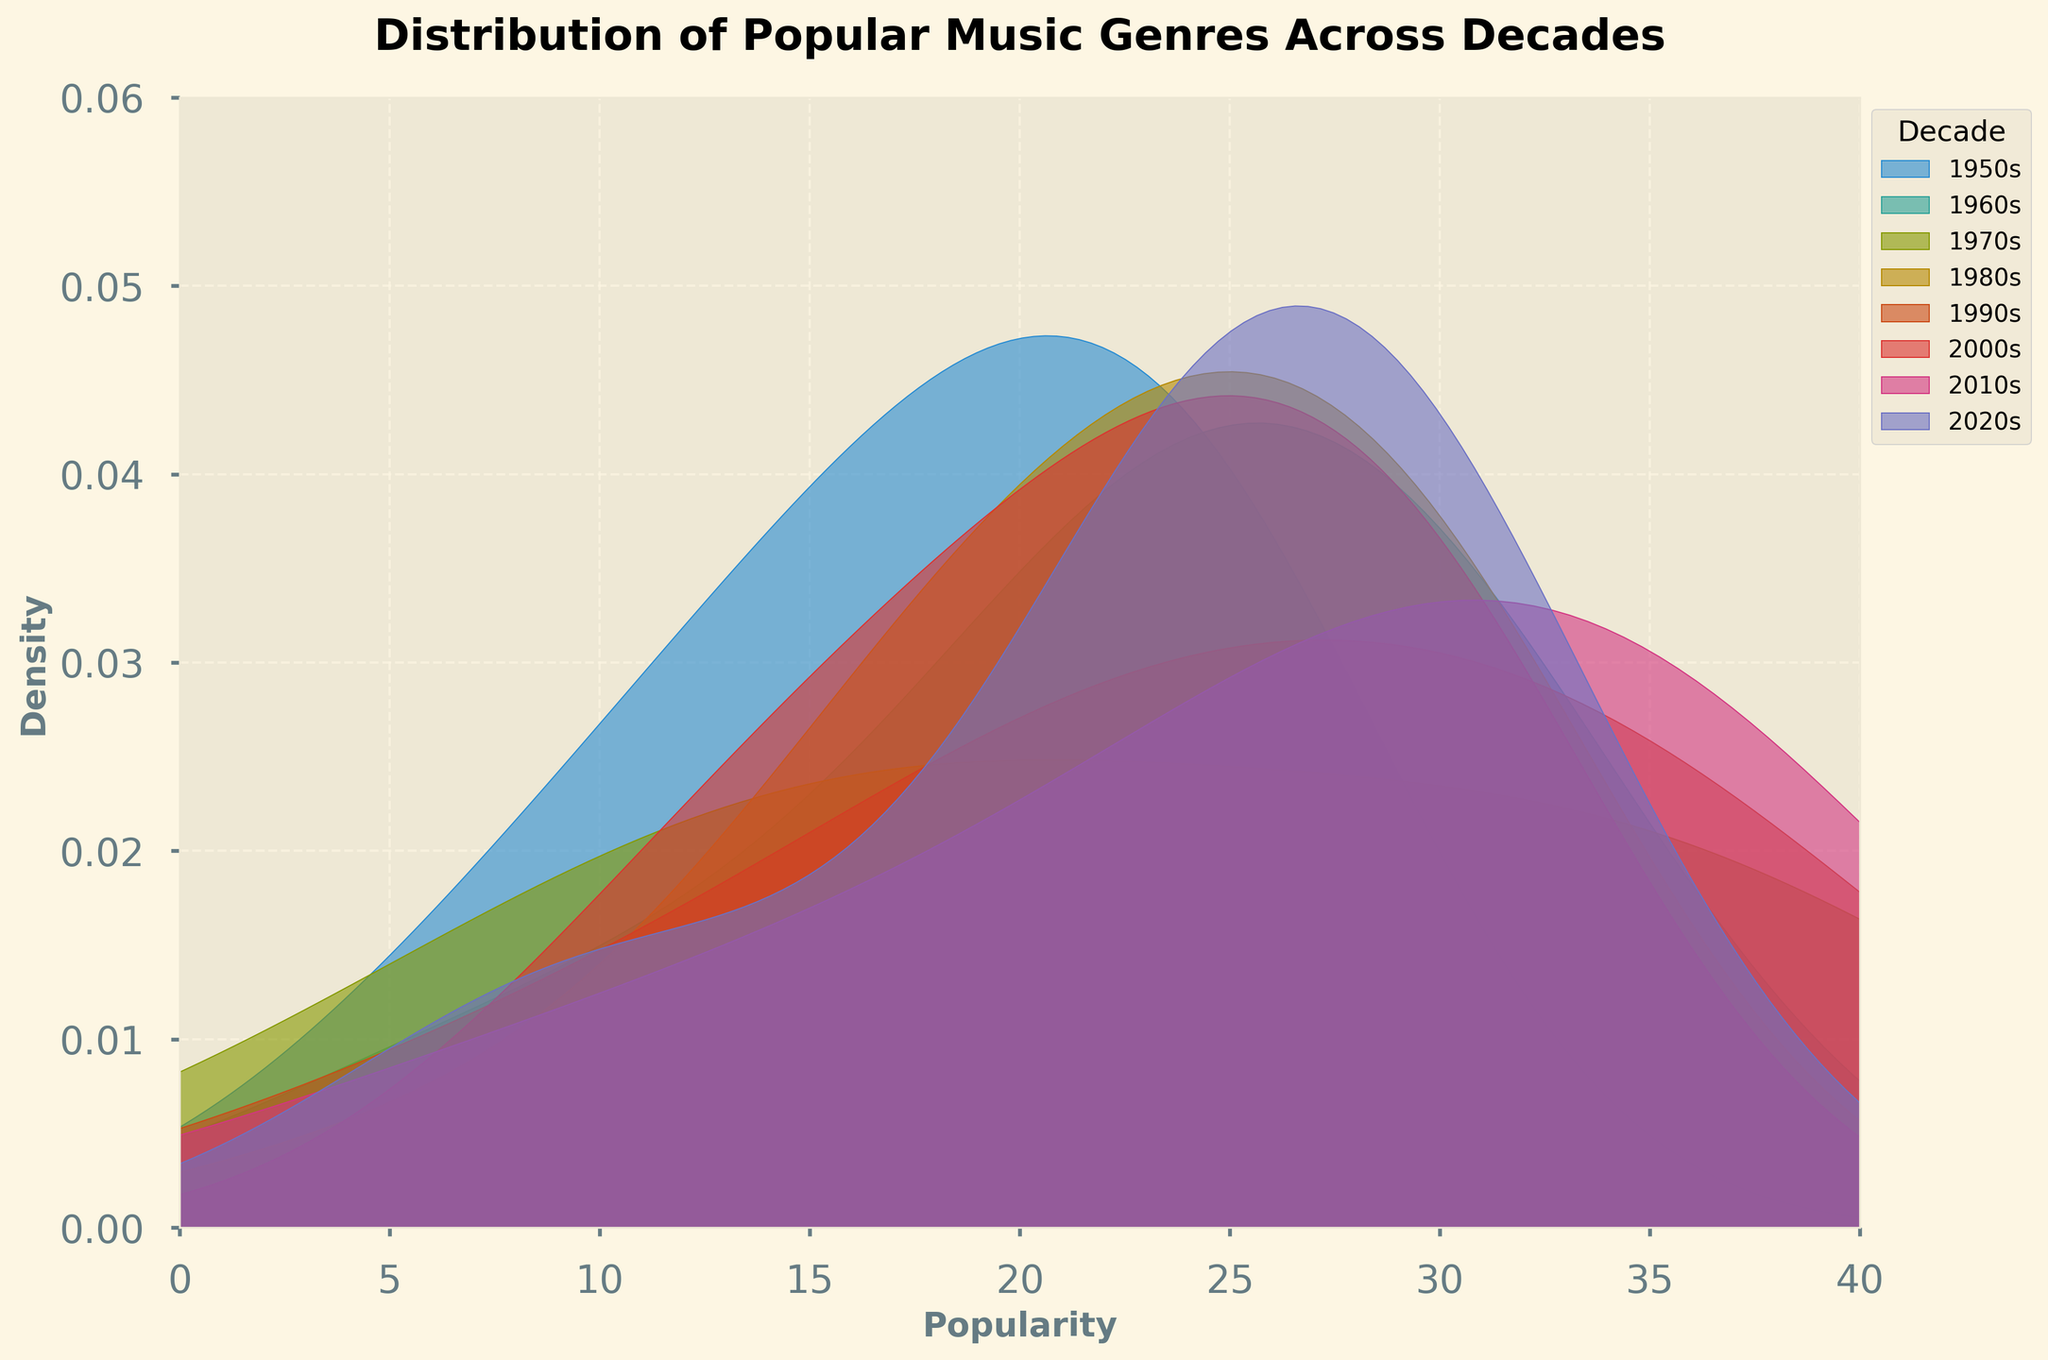What is the title of the figure? The title of the figure is located at the top and it reads "Distribution of Popular Music Genres Across Decades".
Answer: Distribution of Popular Music Genres Across Decades Which decade has the highest peak density? To determine the decade with the highest peak density, we look for the line that reaches the highest point along the density axis.
Answer: 2010s What decade shows the most genres with high popularity? The decade with the most prominent and wider density peaks in the higher range of the popularity axis indicates more genres with high popularity. The width and height combination should be considered in the range above 20 on the popularity scale.
Answer: 2010s How does the popularity distribution of the 1950s compare to the 2020s? Compare the density curves of the 1950s and 2020s. The 1950s shows a lower and narrower peak compared to the 2020s, indicating fewer genres with high popularity. The 2020s have a broader curve indicating more genres with varied high popularity.
Answer: 2020s have higher and broader popularity distribution Which decade shows the smallest density range in popularity? To identify the smallest density range, look for the decade with the shortest span of x-axis values where the density is visibly significant.
Answer: 1950s Between the 1980s and 1990s, which decade had higher popularity in top genres? Compare the density peaks of the 1980s and 1990s. The tallest peak represents the highest popularity within the decade. The density is higher in the range above 25 in the 1990s compared to the 1980s.
Answer: 1990s What is the x-axis representing in the figure? The x-axis at the bottom holds the scale indicating "Popularity", showing how popular the genres were during various decades.
Answer: Popularity What does the y-axis represent and what are its limits? The y-axis represents "Density", specifying the spread and distribution of the popularity values. The limits range from 0 to approximately 0.06.
Answer: Density from 0 to 0.06 How does the density of the 1970s compare to the 2000s around popularity score of 30? By examining the plot around the 30 popularity mark on the x-axis, it can be observed that the 1970s have a smaller density compared to the 2000s.
Answer: 2000s have higher density 